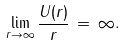Convert formula to latex. <formula><loc_0><loc_0><loc_500><loc_500>\lim _ { r \rightarrow \infty } \frac { U ( r ) } { r } \, = \, \infty .</formula> 